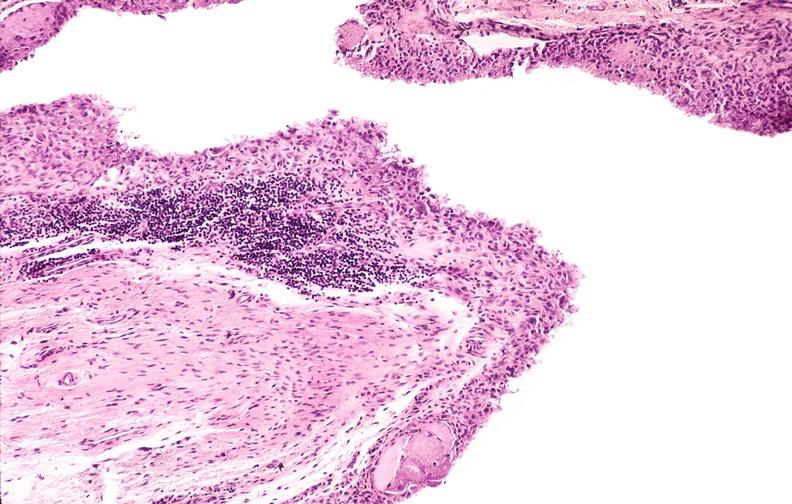what is present?
Answer the question using a single word or phrase. Joints 